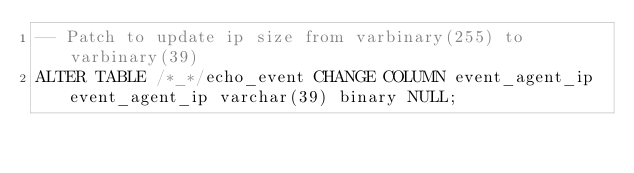<code> <loc_0><loc_0><loc_500><loc_500><_SQL_>-- Patch to update ip size from varbinary(255) to varbinary(39)
ALTER TABLE /*_*/echo_event CHANGE COLUMN event_agent_ip event_agent_ip varchar(39) binary NULL;
</code> 